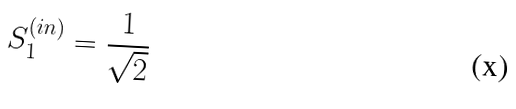Convert formula to latex. <formula><loc_0><loc_0><loc_500><loc_500>S _ { 1 } ^ { ( i n ) } = \frac { 1 } { \sqrt { 2 } }</formula> 